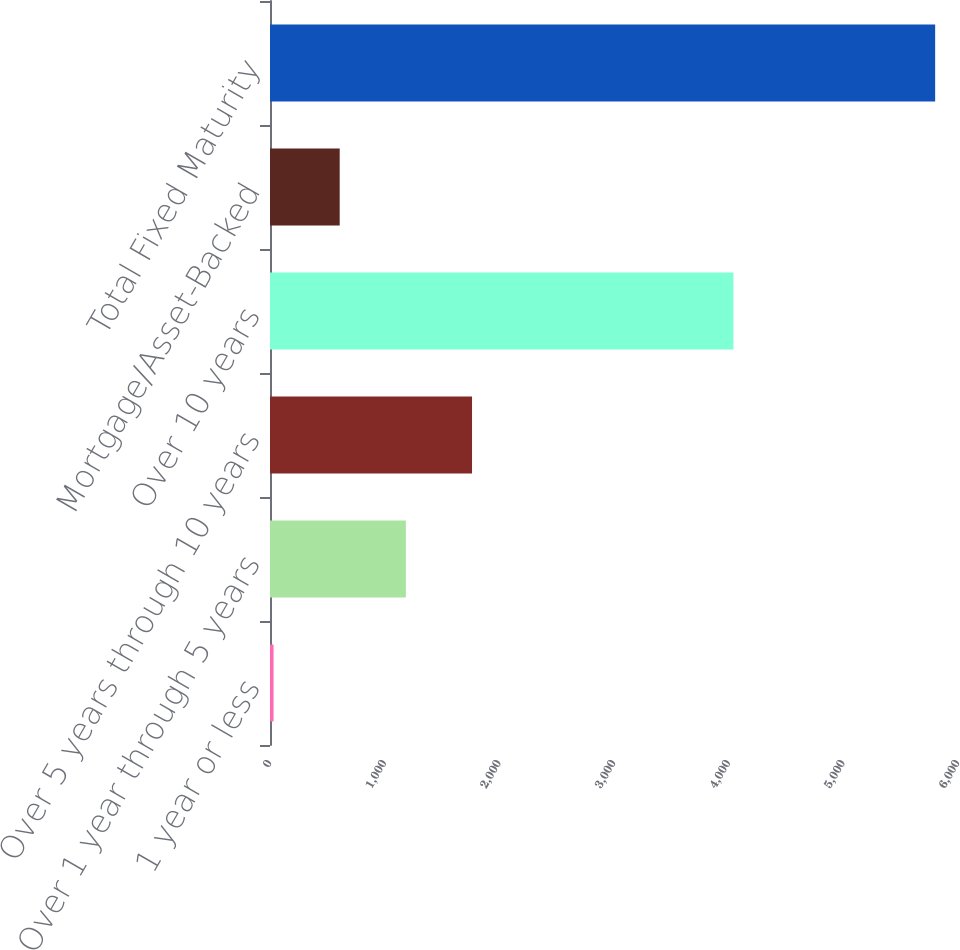<chart> <loc_0><loc_0><loc_500><loc_500><bar_chart><fcel>1 year or less<fcel>Over 1 year through 5 years<fcel>Over 5 years through 10 years<fcel>Over 10 years<fcel>Mortgage/Asset-Backed<fcel>Total Fixed Maturity<nl><fcel>30.9<fcel>1184.88<fcel>1761.87<fcel>4041.4<fcel>607.89<fcel>5800.8<nl></chart> 